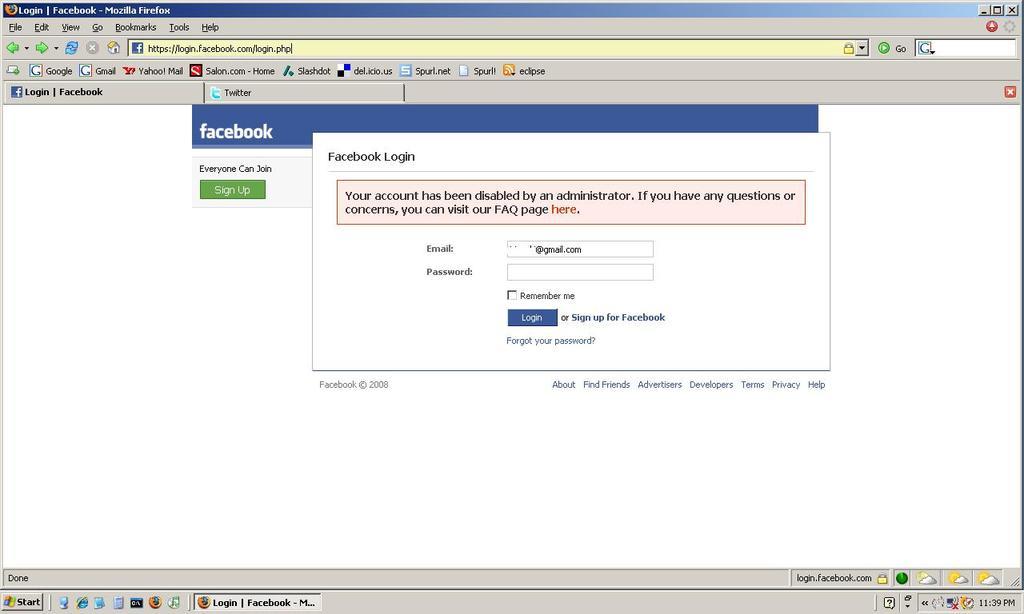What social media website is being used?
Ensure brevity in your answer.  Facebook. 